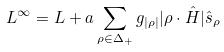<formula> <loc_0><loc_0><loc_500><loc_500>L ^ { \infty } = L + a \sum _ { \rho \in \Delta _ { + } } g _ { | \rho | } | \rho \cdot \hat { H } | \hat { s } _ { \rho }</formula> 